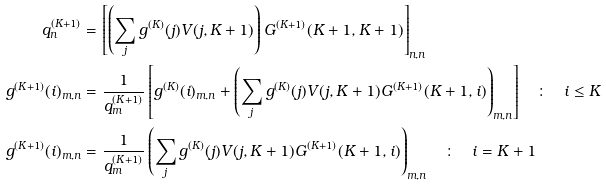Convert formula to latex. <formula><loc_0><loc_0><loc_500><loc_500>q ^ { ( K + 1 ) } _ { n } & = \left [ \left ( \sum _ { j } g ^ { ( K ) } ( j ) V ( j , K + 1 ) \right ) G ^ { ( K + 1 ) } ( K + 1 , K + 1 ) \right ] _ { n , n } \\ g ^ { ( K + 1 ) } ( i ) _ { m , n } & = \frac { 1 } { q ^ { ( K + 1 ) } _ { m } } \left [ g ^ { ( K ) } ( i ) _ { m , n } + \left ( \sum _ { j } g ^ { ( K ) } ( j ) V ( j , K + 1 ) G ^ { ( K + 1 ) } ( K + 1 , i ) \right ) _ { m , n } \right ] \quad \colon \quad i \leq K \\ g ^ { ( K + 1 ) } ( i ) _ { m , n } & = \frac { 1 } { q ^ { ( K + 1 ) } _ { m } } \left ( \sum _ { j } g ^ { ( K ) } ( j ) V ( j , K + 1 ) G ^ { ( K + 1 ) } ( K + 1 , i ) \right ) _ { m , n } \quad \colon \quad i = K + 1 \\</formula> 